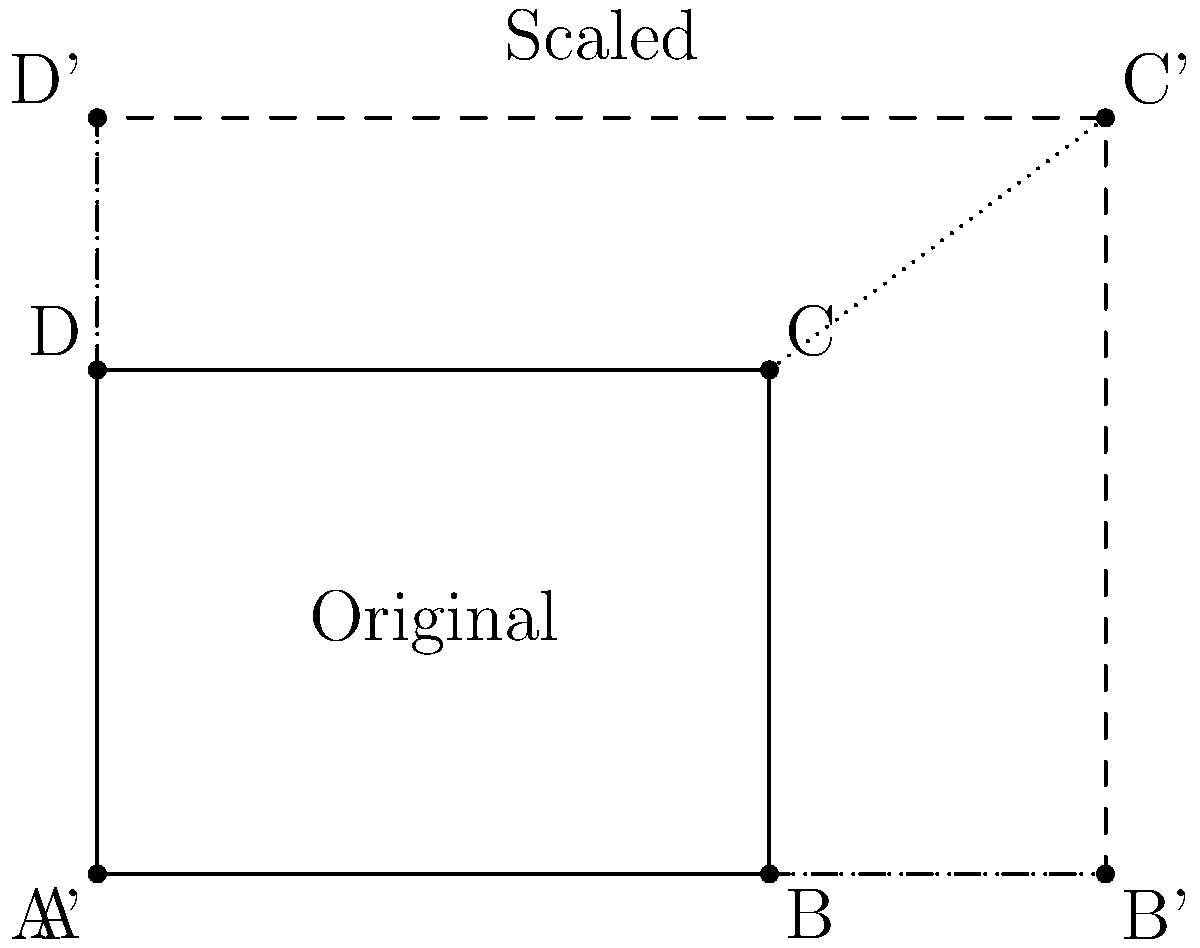A diagram of a quadriceps muscle group is scaled to highlight areas of focus during stretching. The original diagram ABCD is transformed to A'B'C'D' as shown. If the original diagram has a width of 4 units and a height of 3 units, and the scaled diagram has a width of 6 units, what is the scale factor used for this transformation? To find the scale factor, we need to compare the dimensions of the original and scaled diagrams:

1. Original width: 4 units
2. Scaled width: 6 units

Let's calculate the scale factor:

$$ \text{Scale factor} = \frac{\text{Scaled dimension}}{\text{Original dimension}} $$

$$ \text{Scale factor} = \frac{6}{4} = \frac{3}{2} = 1.5 $$

To verify, we can check if this scale factor applies to the height as well:

Original height: 3 units
Expected scaled height: $3 \times 1.5 = 4.5$ units

We can see in the diagram that the scaled height is indeed 4.5 units, confirming our calculation.

Therefore, the scale factor used for this transformation is 1.5 or $\frac{3}{2}$.
Answer: 1.5 